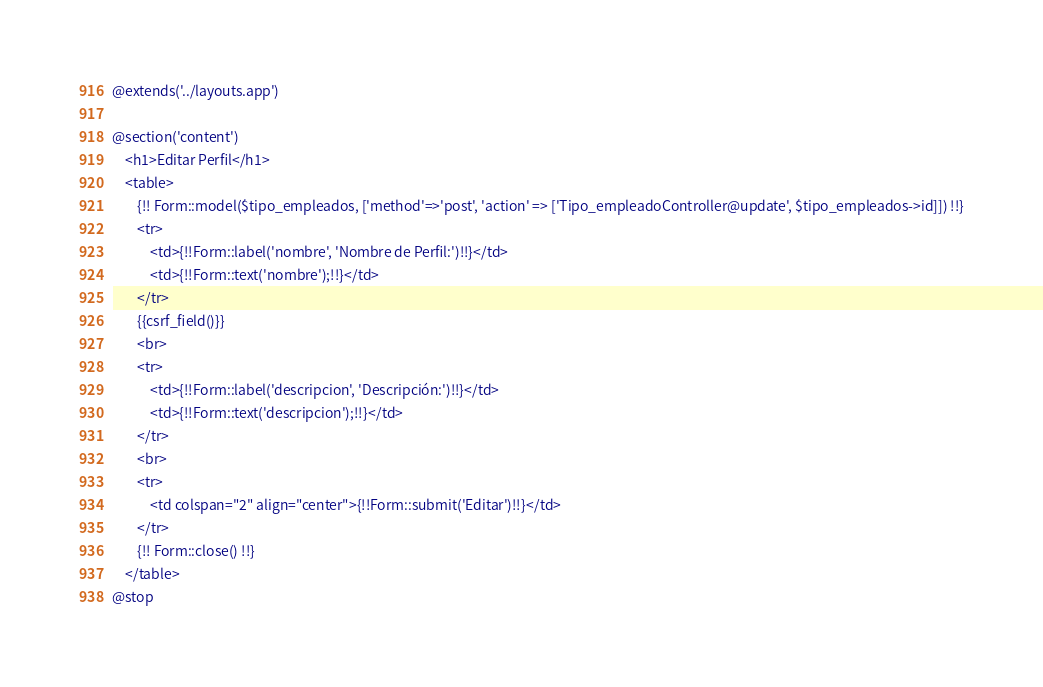Convert code to text. <code><loc_0><loc_0><loc_500><loc_500><_PHP_>@extends('../layouts.app')

@section('content')
    <h1>Editar Perfil</h1>
    <table>
        {!! Form::model($tipo_empleados, ['method'=>'post', 'action' => ['Tipo_empleadoController@update', $tipo_empleados->id]]) !!}
        <tr>
            <td>{!!Form::label('nombre', 'Nombre de Perfil:')!!}</td>
            <td>{!!Form::text('nombre');!!}</td>
        </tr>
        {{csrf_field()}}
        <br>
        <tr>
            <td>{!!Form::label('descripcion', 'Descripción:')!!}</td>
            <td>{!!Form::text('descripcion');!!}</td>
        </tr>
        <br>
        <tr>
            <td colspan="2" align="center">{!!Form::submit('Editar')!!}</td>
        </tr>
        {!! Form::close() !!}
    </table>
@stop</code> 